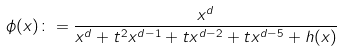<formula> <loc_0><loc_0><loc_500><loc_500>{ } \phi ( x ) \colon = \frac { x ^ { d } } { x ^ { d } + t ^ { 2 } x ^ { d - 1 } + t x ^ { d - 2 } + t x ^ { d - 5 } + h ( x ) }</formula> 